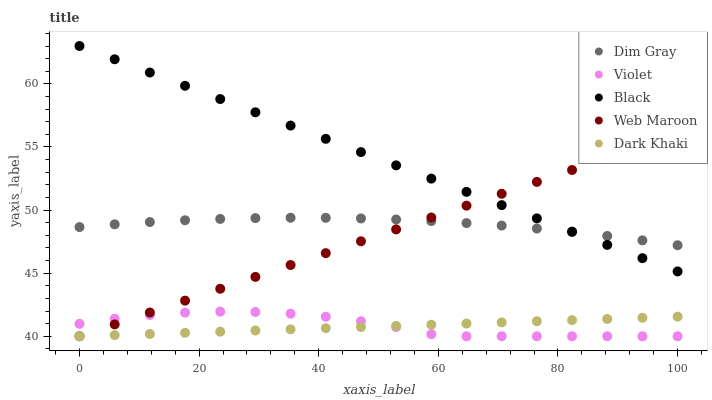Does Dark Khaki have the minimum area under the curve?
Answer yes or no. Yes. Does Black have the maximum area under the curve?
Answer yes or no. Yes. Does Web Maroon have the minimum area under the curve?
Answer yes or no. No. Does Web Maroon have the maximum area under the curve?
Answer yes or no. No. Is Web Maroon the smoothest?
Answer yes or no. Yes. Is Violet the roughest?
Answer yes or no. Yes. Is Dim Gray the smoothest?
Answer yes or no. No. Is Dim Gray the roughest?
Answer yes or no. No. Does Dark Khaki have the lowest value?
Answer yes or no. Yes. Does Dim Gray have the lowest value?
Answer yes or no. No. Does Black have the highest value?
Answer yes or no. Yes. Does Web Maroon have the highest value?
Answer yes or no. No. Is Dark Khaki less than Black?
Answer yes or no. Yes. Is Dim Gray greater than Dark Khaki?
Answer yes or no. Yes. Does Black intersect Web Maroon?
Answer yes or no. Yes. Is Black less than Web Maroon?
Answer yes or no. No. Is Black greater than Web Maroon?
Answer yes or no. No. Does Dark Khaki intersect Black?
Answer yes or no. No. 